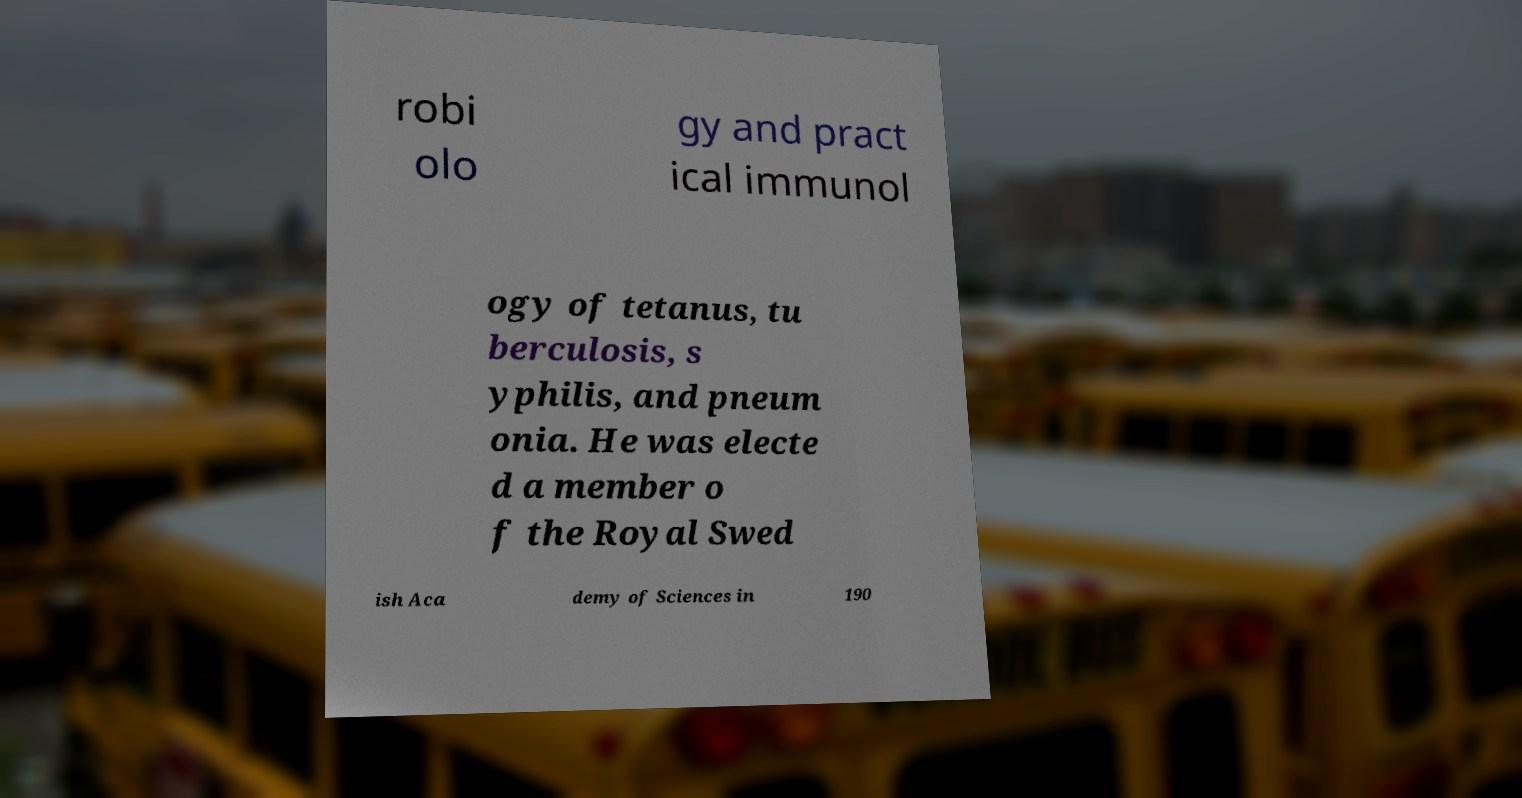Please read and relay the text visible in this image. What does it say? robi olo gy and pract ical immunol ogy of tetanus, tu berculosis, s yphilis, and pneum onia. He was electe d a member o f the Royal Swed ish Aca demy of Sciences in 190 